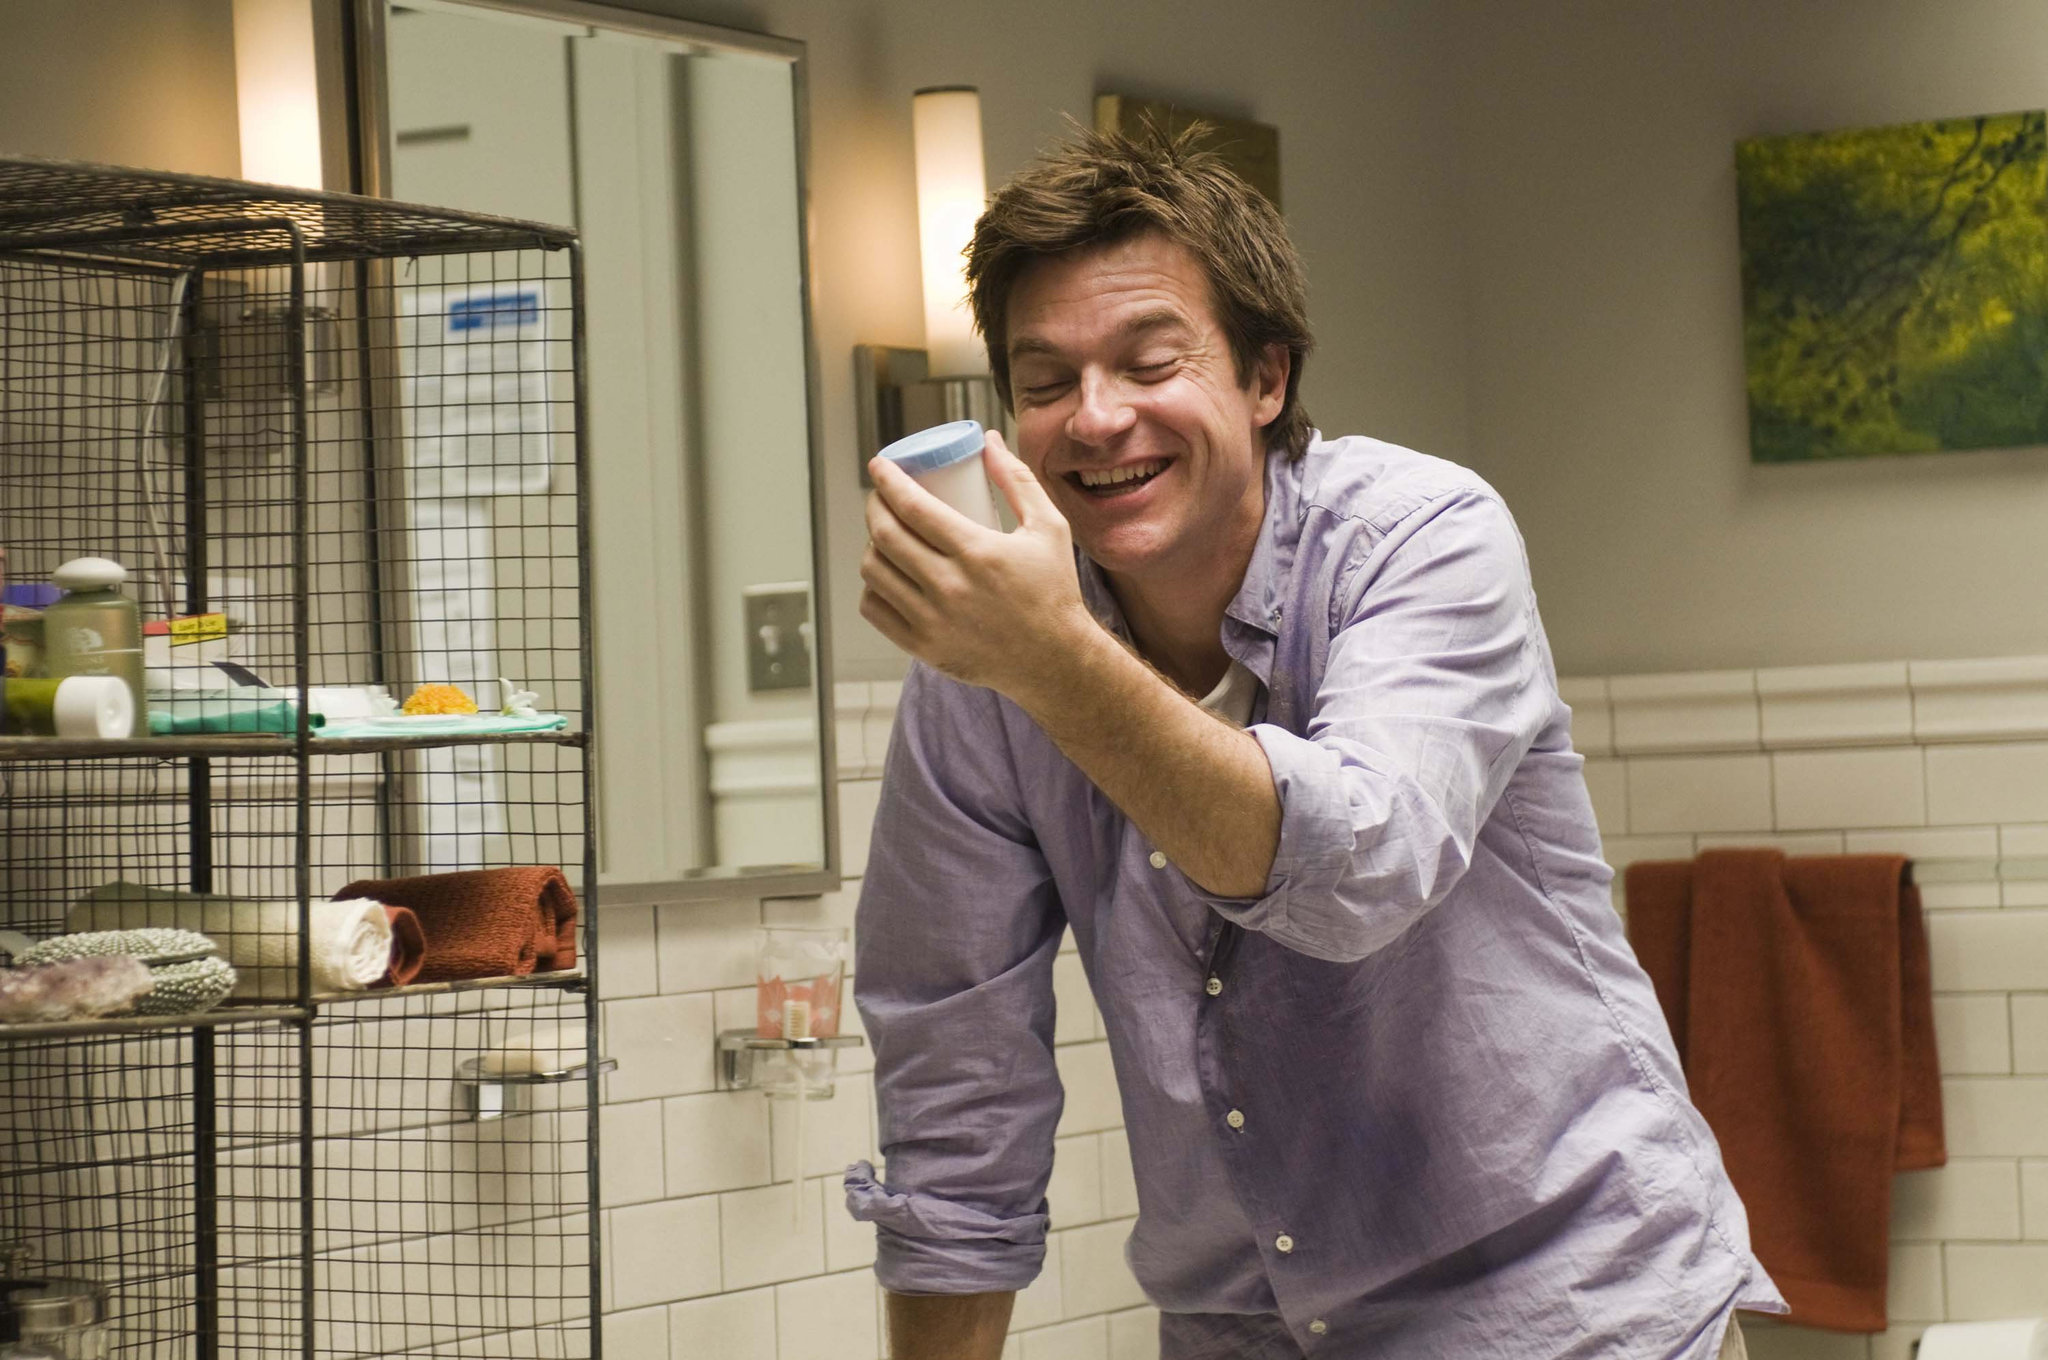What are the man and the bird's daily routine like? Every morning, the man starts his day with a lively burst of energy, his laughter resonating off the white tiles of his bathroom. He greets the yellow bird with a cheerful 'Good morning,' and the bird responds with a series of bright chirps. Together they share the start of the day; the man brushes his teeth, washes his face, and perhaps shares a tune or two with his feathered friend. The bird, perched in its cage, watches over the man's morning rituals, sometimes mimicking the sounds of running water or the hum of an electric toothbrush. As the day goes on, the bird remains a silent witness to the ebb and flow of the man's life - the hurried preparations for work, the spontaneous moments of joy, and even the quiet, reflective times. When night falls, the man bids his avian companion goodnight, covering the cage to signal the end of another shared day. Why would there be a towel draped on the side like that? A towel draped casually on the side might imply a moment of practicality - perhaps the man just finished washing his hands or face and temporarily placed it there. It could also suggest a sense of relaxed comfort, indicating that this bathroom isn't just a place for routine but also a cozy corner of his home where things don't always have to be perfectly ordered. 